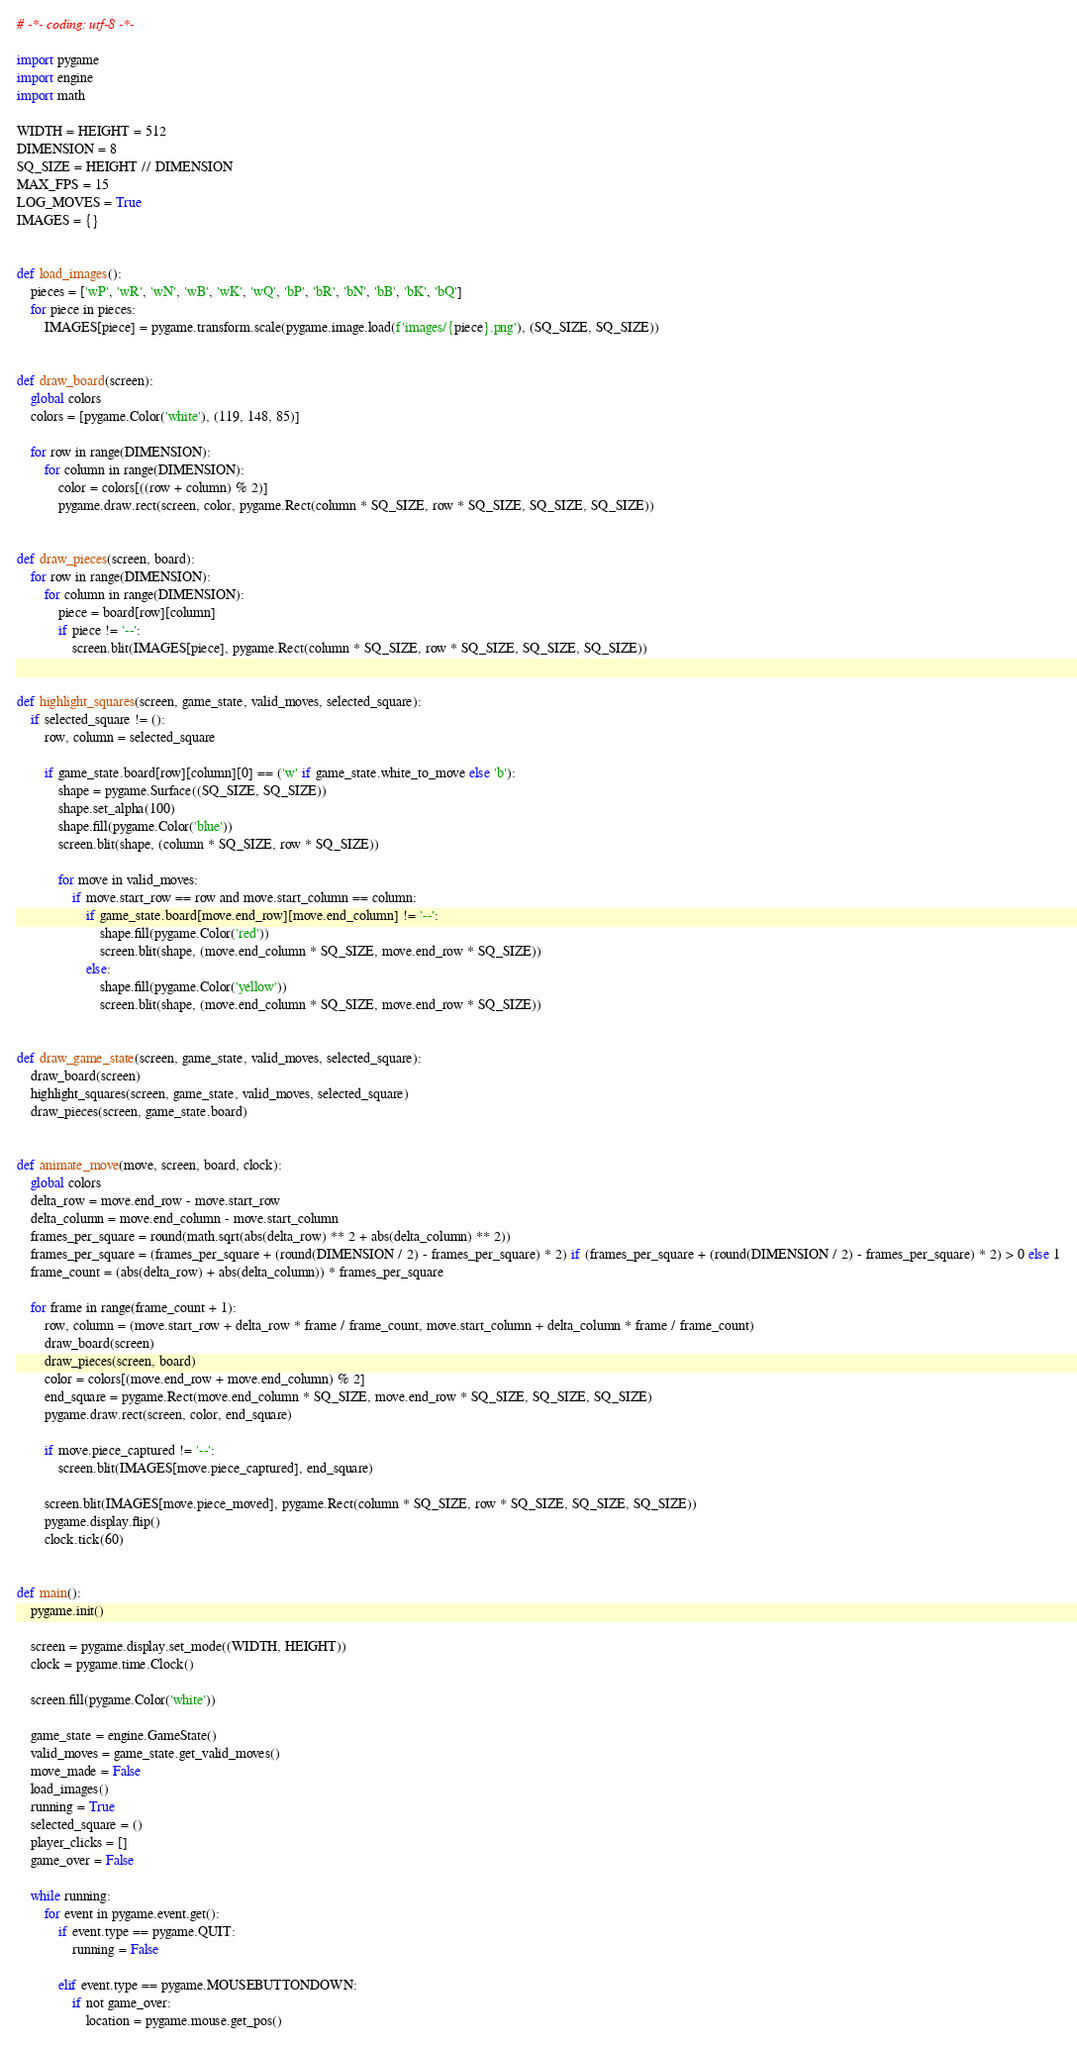<code> <loc_0><loc_0><loc_500><loc_500><_Python_># -*- coding: utf-8 -*-

import pygame
import engine
import math

WIDTH = HEIGHT = 512
DIMENSION = 8
SQ_SIZE = HEIGHT // DIMENSION
MAX_FPS = 15
LOG_MOVES = True
IMAGES = {}


def load_images():
    pieces = ['wP', 'wR', 'wN', 'wB', 'wK', 'wQ', 'bP', 'bR', 'bN', 'bB', 'bK', 'bQ']
    for piece in pieces:
        IMAGES[piece] = pygame.transform.scale(pygame.image.load(f'images/{piece}.png'), (SQ_SIZE, SQ_SIZE))


def draw_board(screen):
    global colors
    colors = [pygame.Color('white'), (119, 148, 85)]

    for row in range(DIMENSION):
        for column in range(DIMENSION):
            color = colors[((row + column) % 2)]
            pygame.draw.rect(screen, color, pygame.Rect(column * SQ_SIZE, row * SQ_SIZE, SQ_SIZE, SQ_SIZE))


def draw_pieces(screen, board):
    for row in range(DIMENSION):
        for column in range(DIMENSION):
            piece = board[row][column]
            if piece != '--':
                screen.blit(IMAGES[piece], pygame.Rect(column * SQ_SIZE, row * SQ_SIZE, SQ_SIZE, SQ_SIZE))


def highlight_squares(screen, game_state, valid_moves, selected_square):
    if selected_square != ():
        row, column = selected_square

        if game_state.board[row][column][0] == ('w' if game_state.white_to_move else 'b'):
            shape = pygame.Surface((SQ_SIZE, SQ_SIZE))
            shape.set_alpha(100)
            shape.fill(pygame.Color('blue'))
            screen.blit(shape, (column * SQ_SIZE, row * SQ_SIZE))

            for move in valid_moves:
                if move.start_row == row and move.start_column == column:
                    if game_state.board[move.end_row][move.end_column] != '--':
                        shape.fill(pygame.Color('red'))
                        screen.blit(shape, (move.end_column * SQ_SIZE, move.end_row * SQ_SIZE))
                    else:
                        shape.fill(pygame.Color('yellow'))
                        screen.blit(shape, (move.end_column * SQ_SIZE, move.end_row * SQ_SIZE))


def draw_game_state(screen, game_state, valid_moves, selected_square):
    draw_board(screen)
    highlight_squares(screen, game_state, valid_moves, selected_square)
    draw_pieces(screen, game_state.board)


def animate_move(move, screen, board, clock):
    global colors
    delta_row = move.end_row - move.start_row
    delta_column = move.end_column - move.start_column
    frames_per_square = round(math.sqrt(abs(delta_row) ** 2 + abs(delta_column) ** 2))
    frames_per_square = (frames_per_square + (round(DIMENSION / 2) - frames_per_square) * 2) if (frames_per_square + (round(DIMENSION / 2) - frames_per_square) * 2) > 0 else 1
    frame_count = (abs(delta_row) + abs(delta_column)) * frames_per_square

    for frame in range(frame_count + 1):
        row, column = (move.start_row + delta_row * frame / frame_count, move.start_column + delta_column * frame / frame_count)
        draw_board(screen)
        draw_pieces(screen, board)
        color = colors[(move.end_row + move.end_column) % 2]
        end_square = pygame.Rect(move.end_column * SQ_SIZE, move.end_row * SQ_SIZE, SQ_SIZE, SQ_SIZE)
        pygame.draw.rect(screen, color, end_square)

        if move.piece_captured != '--':
            screen.blit(IMAGES[move.piece_captured], end_square)

        screen.blit(IMAGES[move.piece_moved], pygame.Rect(column * SQ_SIZE, row * SQ_SIZE, SQ_SIZE, SQ_SIZE))
        pygame.display.flip()
        clock.tick(60)


def main():
    pygame.init()

    screen = pygame.display.set_mode((WIDTH, HEIGHT))
    clock = pygame.time.Clock()

    screen.fill(pygame.Color('white'))

    game_state = engine.GameState()
    valid_moves = game_state.get_valid_moves()
    move_made = False
    load_images()
    running = True
    selected_square = ()
    player_clicks = []
    game_over = False

    while running:
        for event in pygame.event.get():
            if event.type == pygame.QUIT:
                running = False

            elif event.type == pygame.MOUSEBUTTONDOWN:
                if not game_over:
                    location = pygame.mouse.get_pos()</code> 